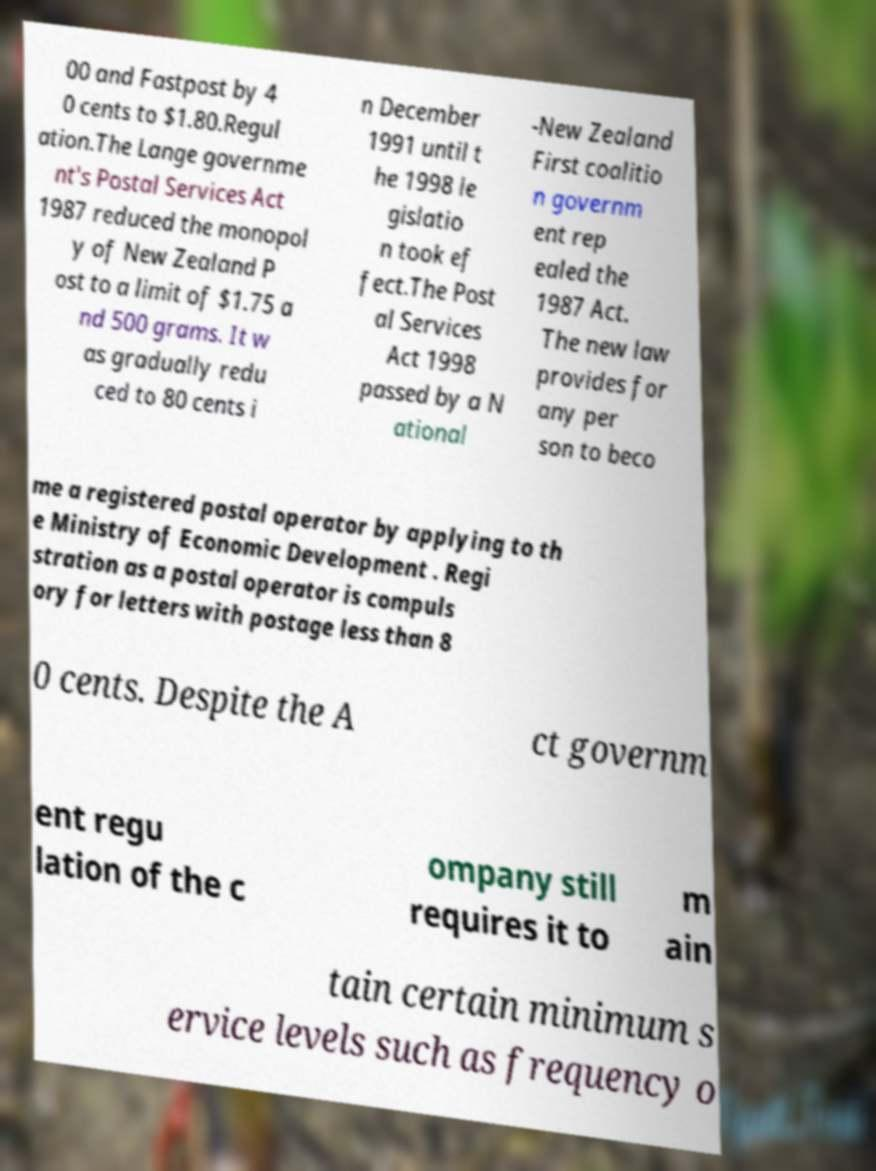Please read and relay the text visible in this image. What does it say? 00 and Fastpost by 4 0 cents to $1.80.Regul ation.The Lange governme nt's Postal Services Act 1987 reduced the monopol y of New Zealand P ost to a limit of $1.75 a nd 500 grams. It w as gradually redu ced to 80 cents i n December 1991 until t he 1998 le gislatio n took ef fect.The Post al Services Act 1998 passed by a N ational -New Zealand First coalitio n governm ent rep ealed the 1987 Act. The new law provides for any per son to beco me a registered postal operator by applying to th e Ministry of Economic Development . Regi stration as a postal operator is compuls ory for letters with postage less than 8 0 cents. Despite the A ct governm ent regu lation of the c ompany still requires it to m ain tain certain minimum s ervice levels such as frequency o 